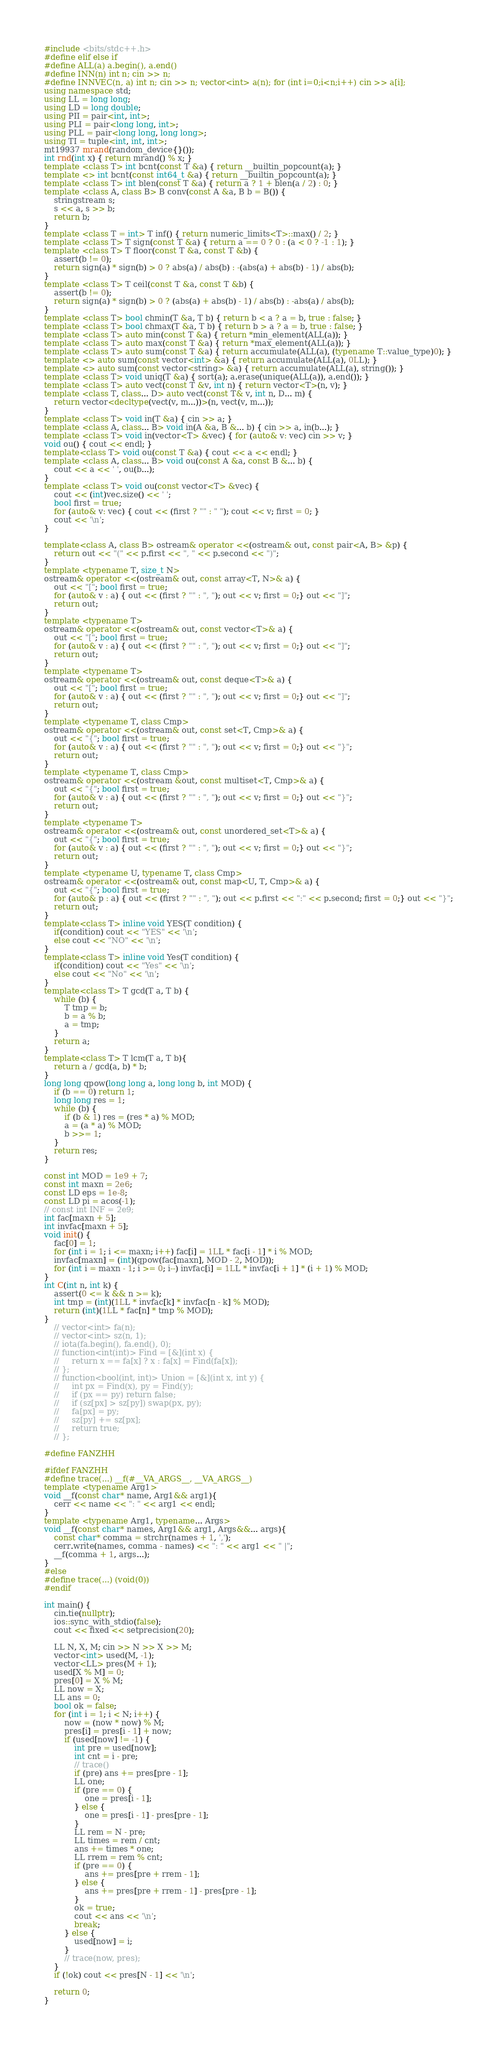Convert code to text. <code><loc_0><loc_0><loc_500><loc_500><_C++_>#include <bits/stdc++.h>
#define elif else if
#define ALL(a) a.begin(), a.end()
#define INN(n) int n; cin >> n;
#define INNVEC(n, a) int n; cin >> n; vector<int> a(n); for (int i=0;i<n;i++) cin >> a[i];
using namespace std;
using LL = long long;
using LD = long double;
using PII = pair<int, int>;
using PLI = pair<long long, int>;
using PLL = pair<long long, long long>;
using TI = tuple<int, int, int>;
mt19937 mrand(random_device{}());
int rnd(int x) { return mrand() % x; }
template <class T> int bcnt(const T &a) { return __builtin_popcount(a); }
template <> int bcnt(const int64_t &a) { return __builtin_popcount(a); }
template <class T> int blen(const T &a) { return a ? 1 + blen(a / 2) : 0; }
template <class A, class B> B conv(const A &a, B b = B()) {
    stringstream s;
    s << a, s >> b;
    return b;
}
template <class T = int> T inf() { return numeric_limits<T>::max() / 2; }
template <class T> T sign(const T &a) { return a == 0 ? 0 : (a < 0 ? -1 : 1); }
template <class T> T floor(const T &a, const T &b) {
    assert(b != 0);
    return sign(a) * sign(b) > 0 ? abs(a) / abs(b) : -(abs(a) + abs(b) - 1) / abs(b);
}
template <class T> T ceil(const T &a, const T &b) {
    assert(b != 0);
    return sign(a) * sign(b) > 0 ? (abs(a) + abs(b) - 1) / abs(b) : -abs(a) / abs(b);
}
template <class T> bool chmin(T &a, T b) { return b < a ? a = b, true : false; }
template <class T> bool chmax(T &a, T b) { return b > a ? a = b, true : false; }
template <class T> auto min(const T &a) { return *min_element(ALL(a)); } 
template <class T> auto max(const T &a) { return *max_element(ALL(a)); }
template <class T> auto sum(const T &a) { return accumulate(ALL(a), (typename T::value_type)0); }
template <> auto sum(const vector<int> &a) { return accumulate(ALL(a), 0LL); }
template <> auto sum(const vector<string> &a) { return accumulate(ALL(a), string()); }
template <class T> void uniq(T &a) { sort(a); a.erase(unique(ALL(a)), a.end()); }
template <class T> auto vect(const T &v, int n) { return vector<T>(n, v); }
template <class T, class... D> auto vect(const T& v, int n, D... m) {
    return vector<decltype(vect(v, m...))>(n, vect(v, m...));
}
template <class T> void in(T &a) { cin >> a; }
template <class A, class... B> void in(A &a, B &... b) { cin >> a, in(b...); }
template <class T> void in(vector<T> &vec) { for (auto& v: vec) cin >> v; }
void ou() { cout << endl; }
template<class T> void ou(const T &a) { cout << a << endl; }
template <class A, class... B> void ou(const A &a, const B &... b) {
    cout << a << ' ', ou(b...);
}
template <class T> void ou(const vector<T> &vec) {
    cout << (int)vec.size() << ' ';
    bool first = true;
    for (auto& v: vec) { cout << (first ? "" : " "); cout << v; first = 0; }
    cout << '\n';
}
 
template<class A, class B> ostream& operator <<(ostream& out, const pair<A, B> &p) {
    return out << "(" << p.first << ", " << p.second << ")";
}
template <typename T, size_t N>
ostream& operator <<(ostream& out, const array<T, N>& a) {
    out << "["; bool first = true;
    for (auto& v : a) { out << (first ? "" : ", "); out << v; first = 0;} out << "]";
    return out;
}
template <typename T>
ostream& operator <<(ostream& out, const vector<T>& a) {
    out << "["; bool first = true;
    for (auto& v : a) { out << (first ? "" : ", "); out << v; first = 0;} out << "]";
    return out;
}
template <typename T>
ostream& operator <<(ostream& out, const deque<T>& a) {
    out << "["; bool first = true;
    for (auto& v : a) { out << (first ? "" : ", "); out << v; first = 0;} out << "]";
    return out;
}
template <typename T, class Cmp>
ostream& operator <<(ostream& out, const set<T, Cmp>& a) {
    out << "{"; bool first = true;
    for (auto& v : a) { out << (first ? "" : ", "); out << v; first = 0;} out << "}";
    return out;
}
template <typename T, class Cmp>
ostream& operator <<(ostream &out, const multiset<T, Cmp>& a) {
    out << "{"; bool first = true;
    for (auto& v : a) { out << (first ? "" : ", "); out << v; first = 0;} out << "}";
    return out;
}
template <typename T>
ostream& operator <<(ostream& out, const unordered_set<T>& a) {
    out << "{"; bool first = true;
    for (auto& v : a) { out << (first ? "" : ", "); out << v; first = 0;} out << "}";
    return out;
}
template <typename U, typename T, class Cmp>
ostream& operator <<(ostream& out, const map<U, T, Cmp>& a) {
    out << "{"; bool first = true;
    for (auto& p : a) { out << (first ? "" : ", "); out << p.first << ":" << p.second; first = 0;} out << "}";
    return out;
}
template<class T> inline void YES(T condition) { 
    if(condition) cout << "YES" << '\n';
    else cout << "NO" << '\n';
}
template<class T> inline void Yes(T condition) {
    if(condition) cout << "Yes" << '\n';
    else cout << "No" << '\n';
}
template<class T> T gcd(T a, T b) {
    while (b) {
        T tmp = b;
        b = a % b;
        a = tmp;
    }
    return a;
}
template<class T> T lcm(T a, T b){
    return a / gcd(a, b) * b;
}
long long qpow(long long a, long long b, int MOD) {
    if (b == 0) return 1;
    long long res = 1;
    while (b) {
        if (b & 1) res = (res * a) % MOD;
        a = (a * a) % MOD;
        b >>= 1;
    }
    return res;
}
 
const int MOD = 1e9 + 7;
const int maxn = 2e6;
const LD eps = 1e-8;
const LD pi = acos(-1);
// const int INF = 2e9;
int fac[maxn + 5];
int invfac[maxn + 5];
void init() {
    fac[0] = 1;
    for (int i = 1; i <= maxn; i++) fac[i] = 1LL * fac[i - 1] * i % MOD;
    invfac[maxn] = (int)(qpow(fac[maxn], MOD - 2, MOD));
    for (int i = maxn - 1; i >= 0; i--) invfac[i] = 1LL * invfac[i + 1] * (i + 1) % MOD;
}
int C(int n, int k) {
    assert(0 <= k && n >= k);
    int tmp = (int)(1LL * invfac[k] * invfac[n - k] % MOD);
    return (int)(1LL * fac[n] * tmp % MOD);
}
    // vector<int> fa(n);
    // vector<int> sz(n, 1);
    // iota(fa.begin(), fa.end(), 0);
    // function<int(int)> Find = [&](int x) {
    //     return x == fa[x] ? x : fa[x] = Find(fa[x]);
    // };
    // function<bool(int, int)> Union = [&](int x, int y) {
    //     int px = Find(x), py = Find(y);
    //     if (px == py) return false;
    //     if (sz[px] > sz[py]) swap(px, py);
    //     fa[px] = py;
    //     sz[py] += sz[px];
    //     return true;
    // };
 
#define FANZHH
 
#ifdef FANZHH
#define trace(...) __f(#__VA_ARGS__, __VA_ARGS__)
template <typename Arg1>
void __f(const char* name, Arg1&& arg1){
    cerr << name << ": " << arg1 << endl;
}
template <typename Arg1, typename... Args>
void __f(const char* names, Arg1&& arg1, Args&&... args){
    const char* comma = strchr(names + 1, ',');
    cerr.write(names, comma - names) << ": " << arg1 << " |";
    __f(comma + 1, args...);
}
#else
#define trace(...) (void(0))
#endif

int main() {
    cin.tie(nullptr);
    ios::sync_with_stdio(false);
    cout << fixed << setprecision(20);

    LL N, X, M; cin >> N >> X >> M;
    vector<int> used(M, -1);
    vector<LL> pres(M + 1);
    used[X % M] = 0;
    pres[0] = X % M;
    LL now = X;
    LL ans = 0;
    bool ok = false;
    for (int i = 1; i < N; i++) {
        now = (now * now) % M;
        pres[i] = pres[i - 1] + now;
        if (used[now] != -1) {
            int pre = used[now];
            int cnt = i - pre;
            // trace()
            if (pre) ans += pres[pre - 1];
            LL one;
            if (pre == 0) {
                one = pres[i - 1];
            } else {
                one = pres[i - 1] - pres[pre - 1];
            }
            LL rem = N - pre;
            LL times = rem / cnt;
            ans += times * one;
            LL rrem = rem % cnt;
            if (pre == 0) {
                ans += pres[pre + rrem - 1];
            } else {
                ans += pres[pre + rrem - 1] - pres[pre - 1];
            }
            ok = true;
            cout << ans << '\n';
            break;
        } else {
            used[now] = i;
        }
        // trace(now, pres);
    }
    if (!ok) cout << pres[N - 1] << '\n';

    return 0;
}
</code> 